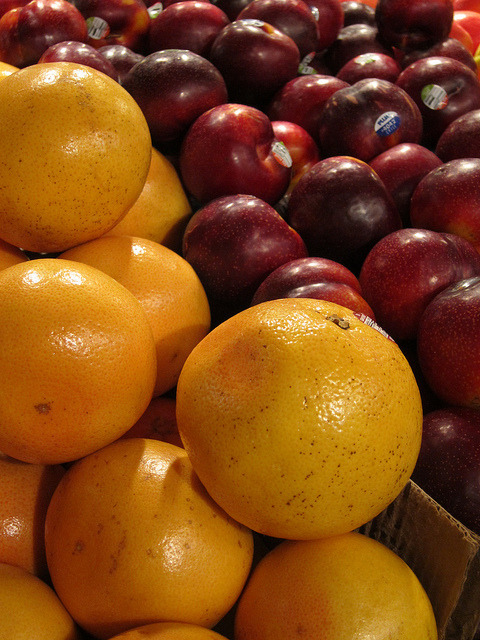Can one fruit be sliced and juiced?
Answer the question using a single word or phrase. Yes Could you make a pie out of the fruits on the left? No How many cherries are there? 0 